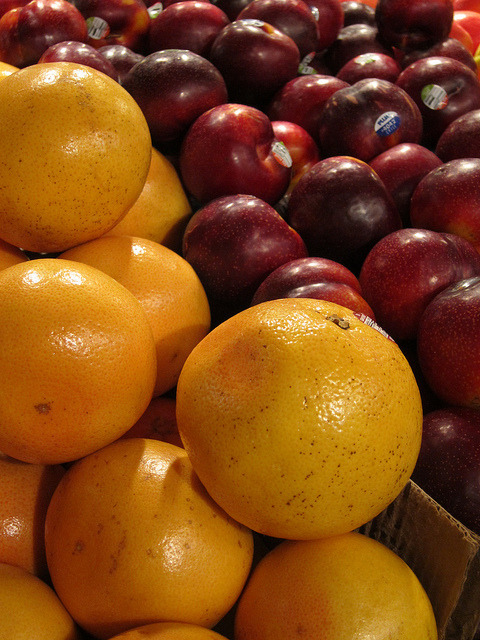Can one fruit be sliced and juiced?
Answer the question using a single word or phrase. Yes Could you make a pie out of the fruits on the left? No How many cherries are there? 0 